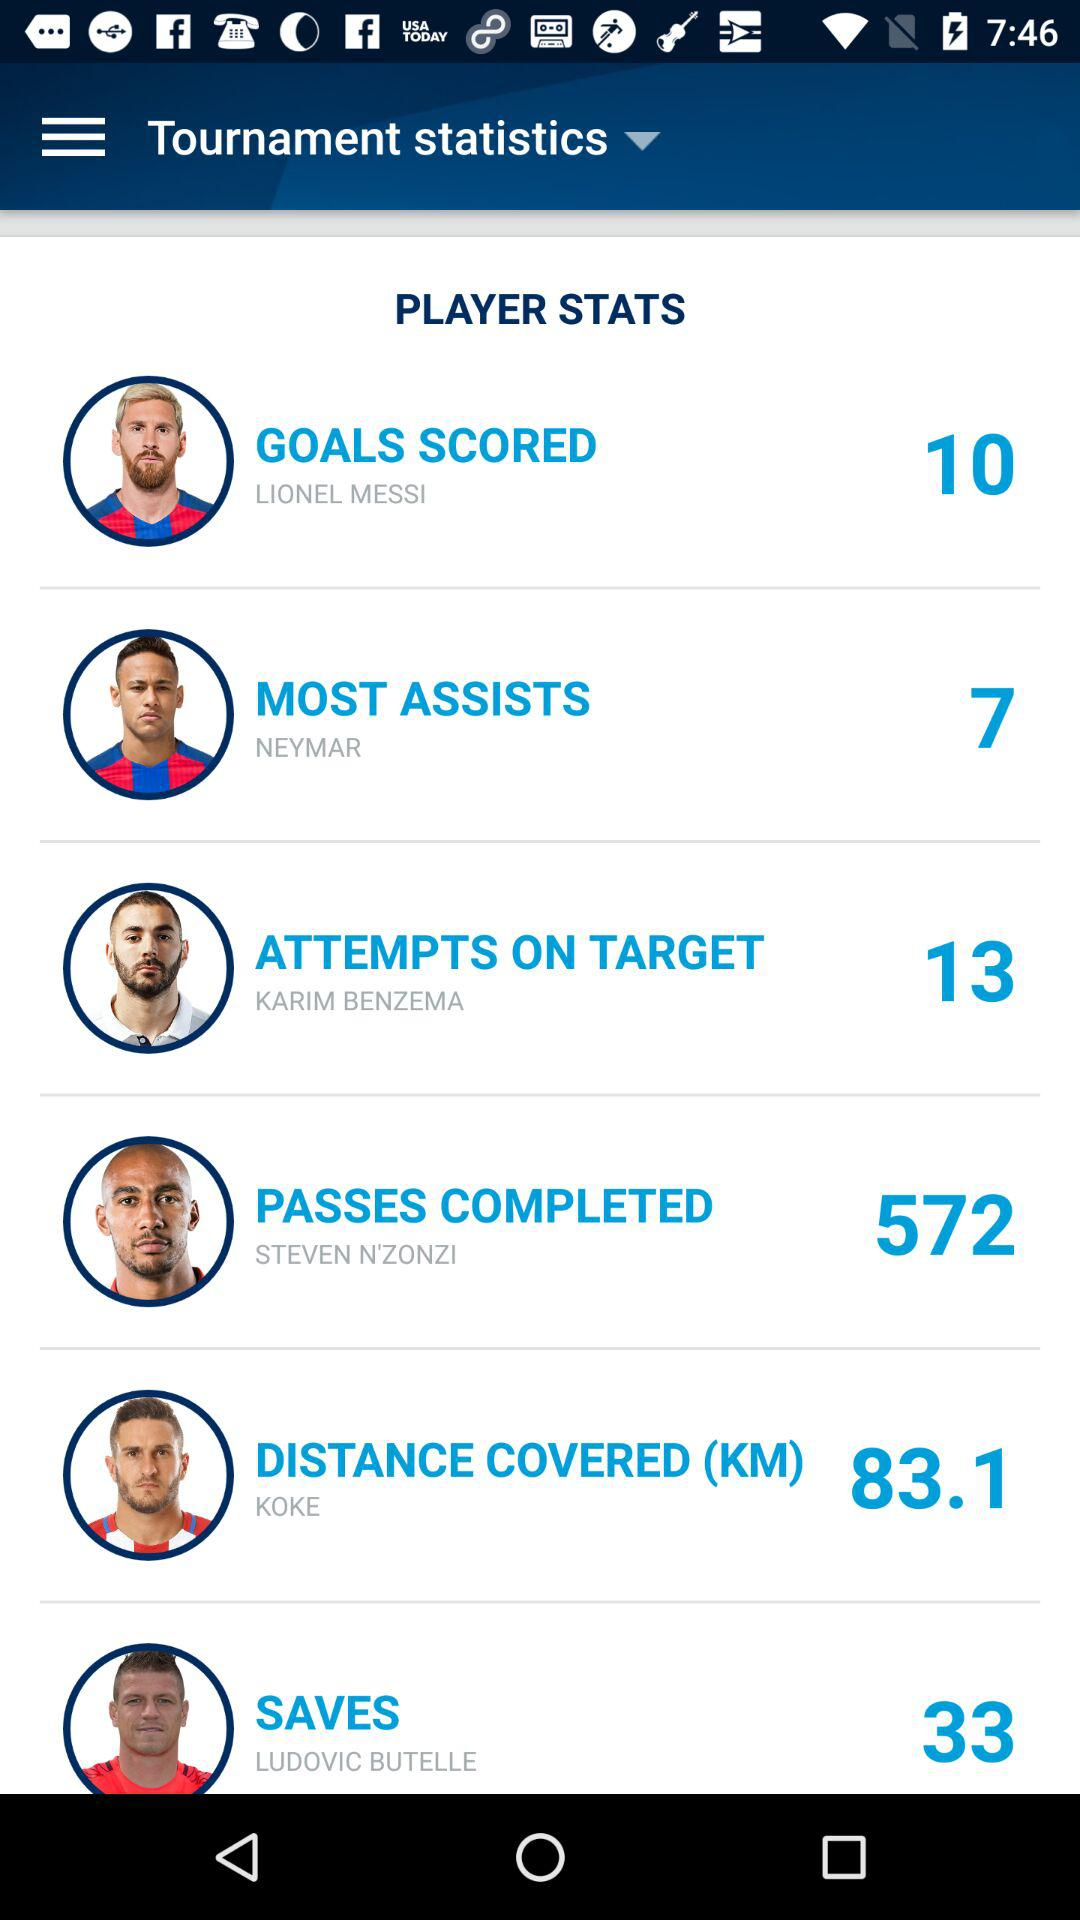What is the number of passes completed by Steven N'Zonzi? The number of passes completed by Steven N'Zonzi is 572. 